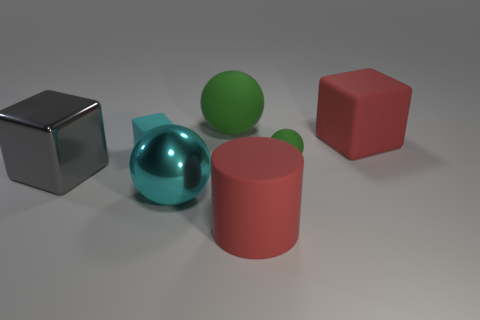What is the size of the object that is the same color as the large rubber block?
Ensure brevity in your answer.  Large. The tiny cube is what color?
Ensure brevity in your answer.  Cyan. What color is the sphere that is both in front of the large green matte ball and right of the large cyan shiny thing?
Give a very brief answer. Green. What color is the tiny object that is left of the green matte sphere in front of the small cube that is in front of the large red block?
Give a very brief answer. Cyan. There is a rubber cube that is the same size as the rubber cylinder; what is its color?
Provide a short and direct response. Red. There is a big shiny thing that is behind the large sphere that is in front of the green sphere left of the large cylinder; what is its shape?
Your answer should be compact. Cube. The object that is the same color as the big cylinder is what shape?
Offer a very short reply. Cube. How many things are either large green shiny things or big metallic objects in front of the gray shiny cube?
Provide a short and direct response. 1. Do the red rubber object that is behind the gray metal object and the small cyan thing have the same size?
Your answer should be very brief. No. What material is the large ball that is in front of the large green rubber sphere?
Your response must be concise. Metal. 